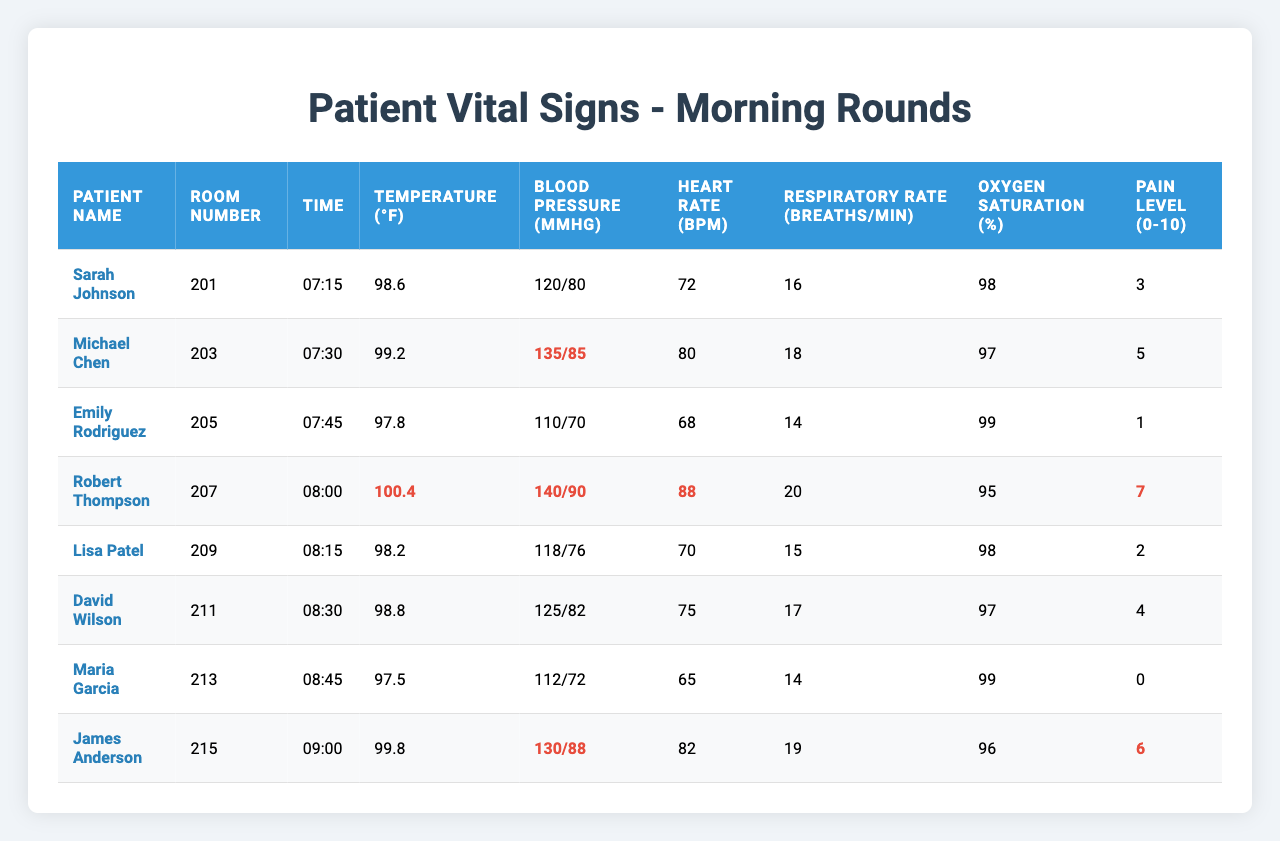What is the temperature of Robert Thompson? Looking at the row for Robert Thompson, the temperature recorded is 100.4 °F.
Answer: 100.4 °F What is the room number for Emily Rodriguez? Referring to the table, Emily Rodriguez is in room number 205.
Answer: 205 What is the heart rate of Sarah Johnson? The table shows that Sarah Johnson has a heart rate of 72 bpm.
Answer: 72 bpm Is David Wilson's blood pressure within normal limits? David Wilson's blood pressure is 125/82 mmHg, which is considered normal (systolic ≤ 130 and diastolic ≤ 85).
Answer: Yes What is the range of oxygen saturation levels recorded? The oxygen saturation levels range from 95% (Robert Thompson) to 99% (Emily Rodriguez and Maria Garcia). Therefore, the range is 95% to 99%.
Answer: 95% to 99% Which patient reported the highest pain level, and what was it? Robert Thompson reported the highest pain level at 7, which is identifiable in the pain level column.
Answer: Robert Thompson; 7 What is the average respiratory rate of all patients recorded? The respiratory rates of all patients are 16, 18, 14, 20, 15, 17, 14, and 19. Summing these gives 16 + 18 + 14 + 20 + 15 + 17 + 14 + 19 = 133. Dividing by 8 gives an average of 133/8 = 16.625, therefore rounding down, the average is 17.
Answer: 17 Which patients have heart rates above 85 bpm? The patients with heart rates above 85 bpm are Robert Thompson (88 bpm) and James Anderson (82 bpm).
Answer: Robert Thompson; James Anderson What is the total number of patients with a pain level greater than 5? Referring to the pain levels, Robert Thompson (7) and James Anderson (6) both have pain levels above 5, which sums up to 2 patients.
Answer: 2 Which patient has the lowest recorded oxygen saturation? The lowest recorded oxygen saturation level is 95% for Robert Thompson, as indicated in the saturation column.
Answer: Robert Thompson; 95% 